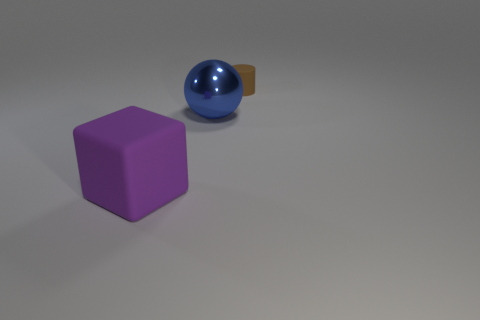How would you describe the composition of the objects in this image? The composition of the objects in the image is simple yet balanced. The three objects vary in size, shape, and color, creating visual interest and a sense of depth. The placement of the objects leads the eye from the left to the right of the image. 